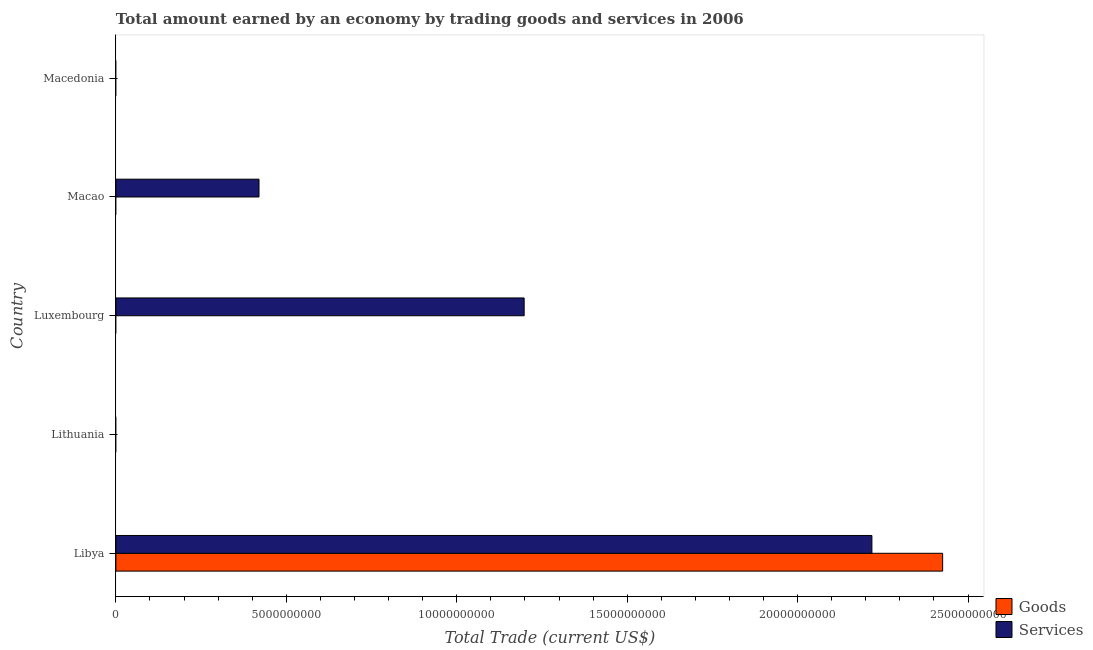How many different coloured bars are there?
Your answer should be very brief. 2. Are the number of bars per tick equal to the number of legend labels?
Keep it short and to the point. No. Are the number of bars on each tick of the Y-axis equal?
Make the answer very short. No. How many bars are there on the 3rd tick from the top?
Your response must be concise. 1. How many bars are there on the 1st tick from the bottom?
Make the answer very short. 2. What is the label of the 4th group of bars from the top?
Your answer should be compact. Lithuania. In how many cases, is the number of bars for a given country not equal to the number of legend labels?
Your response must be concise. 4. What is the amount earned by trading goods in Macao?
Keep it short and to the point. 0. Across all countries, what is the maximum amount earned by trading goods?
Keep it short and to the point. 2.43e+1. Across all countries, what is the minimum amount earned by trading goods?
Make the answer very short. 0. In which country was the amount earned by trading goods maximum?
Give a very brief answer. Libya. What is the total amount earned by trading goods in the graph?
Your response must be concise. 2.43e+1. What is the difference between the amount earned by trading services in Luxembourg and that in Macao?
Your response must be concise. 7.78e+09. What is the difference between the amount earned by trading services in Libya and the amount earned by trading goods in Macedonia?
Offer a terse response. 2.22e+1. What is the average amount earned by trading goods per country?
Provide a short and direct response. 4.85e+09. What is the difference between the amount earned by trading goods and amount earned by trading services in Libya?
Keep it short and to the point. 2.08e+09. What is the ratio of the amount earned by trading services in Libya to that in Macao?
Make the answer very short. 5.28. What is the difference between the highest and the second highest amount earned by trading services?
Ensure brevity in your answer.  1.02e+1. What is the difference between the highest and the lowest amount earned by trading services?
Your answer should be very brief. 2.22e+1. Are the values on the major ticks of X-axis written in scientific E-notation?
Keep it short and to the point. No. Does the graph contain grids?
Provide a short and direct response. No. How are the legend labels stacked?
Provide a succinct answer. Vertical. What is the title of the graph?
Keep it short and to the point. Total amount earned by an economy by trading goods and services in 2006. What is the label or title of the X-axis?
Ensure brevity in your answer.  Total Trade (current US$). What is the Total Trade (current US$) in Goods in Libya?
Your answer should be compact. 2.43e+1. What is the Total Trade (current US$) of Services in Libya?
Provide a succinct answer. 2.22e+1. What is the Total Trade (current US$) in Services in Luxembourg?
Provide a short and direct response. 1.20e+1. What is the Total Trade (current US$) in Goods in Macao?
Give a very brief answer. 0. What is the Total Trade (current US$) in Services in Macao?
Your answer should be compact. 4.20e+09. Across all countries, what is the maximum Total Trade (current US$) of Goods?
Offer a terse response. 2.43e+1. Across all countries, what is the maximum Total Trade (current US$) in Services?
Your response must be concise. 2.22e+1. Across all countries, what is the minimum Total Trade (current US$) in Goods?
Provide a short and direct response. 0. Across all countries, what is the minimum Total Trade (current US$) in Services?
Offer a terse response. 0. What is the total Total Trade (current US$) of Goods in the graph?
Offer a very short reply. 2.43e+1. What is the total Total Trade (current US$) in Services in the graph?
Give a very brief answer. 3.84e+1. What is the difference between the Total Trade (current US$) in Services in Libya and that in Luxembourg?
Your answer should be very brief. 1.02e+1. What is the difference between the Total Trade (current US$) in Services in Libya and that in Macao?
Your response must be concise. 1.80e+1. What is the difference between the Total Trade (current US$) in Services in Luxembourg and that in Macao?
Ensure brevity in your answer.  7.78e+09. What is the difference between the Total Trade (current US$) in Goods in Libya and the Total Trade (current US$) in Services in Luxembourg?
Provide a succinct answer. 1.23e+1. What is the difference between the Total Trade (current US$) in Goods in Libya and the Total Trade (current US$) in Services in Macao?
Your answer should be compact. 2.01e+1. What is the average Total Trade (current US$) in Goods per country?
Make the answer very short. 4.85e+09. What is the average Total Trade (current US$) in Services per country?
Ensure brevity in your answer.  7.67e+09. What is the difference between the Total Trade (current US$) of Goods and Total Trade (current US$) of Services in Libya?
Keep it short and to the point. 2.08e+09. What is the ratio of the Total Trade (current US$) of Services in Libya to that in Luxembourg?
Your response must be concise. 1.85. What is the ratio of the Total Trade (current US$) in Services in Libya to that in Macao?
Offer a terse response. 5.28. What is the ratio of the Total Trade (current US$) of Services in Luxembourg to that in Macao?
Your answer should be compact. 2.85. What is the difference between the highest and the second highest Total Trade (current US$) in Services?
Offer a terse response. 1.02e+1. What is the difference between the highest and the lowest Total Trade (current US$) in Goods?
Your answer should be very brief. 2.43e+1. What is the difference between the highest and the lowest Total Trade (current US$) in Services?
Your answer should be compact. 2.22e+1. 